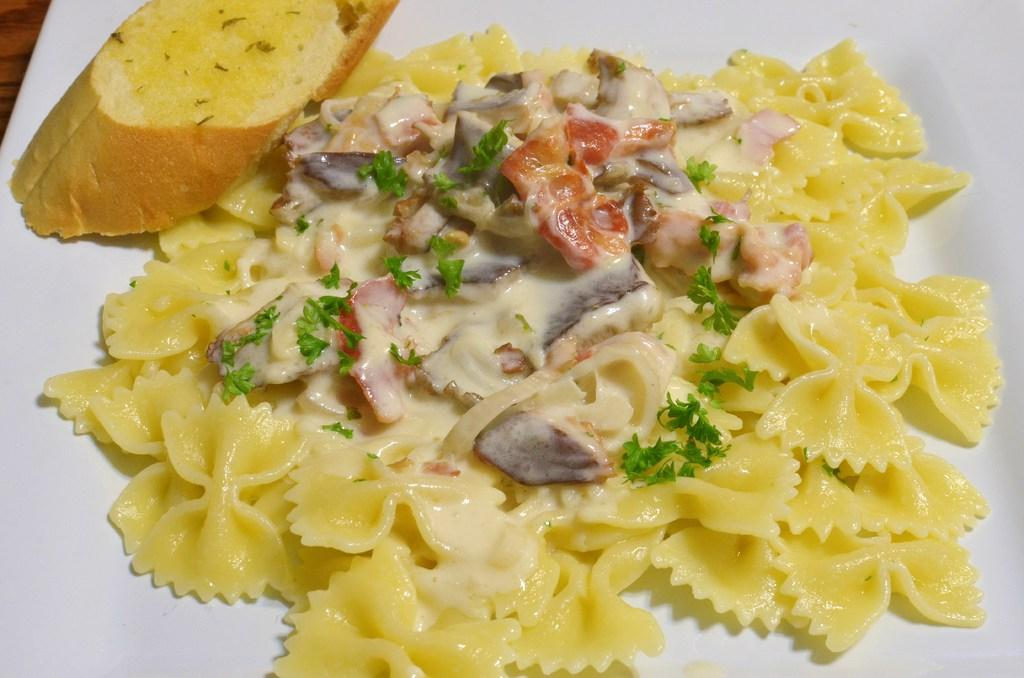What is the main food item on the plate in the image? There is a food item on a plate in the image, but the specific type of food is not mentioned. Can you identify any other items on the plate? Yes, there is a bread piece on the plate in the image. What news is being reported by the rod in the image? There is no rod present in the image, and therefore no news can be reported by it. 